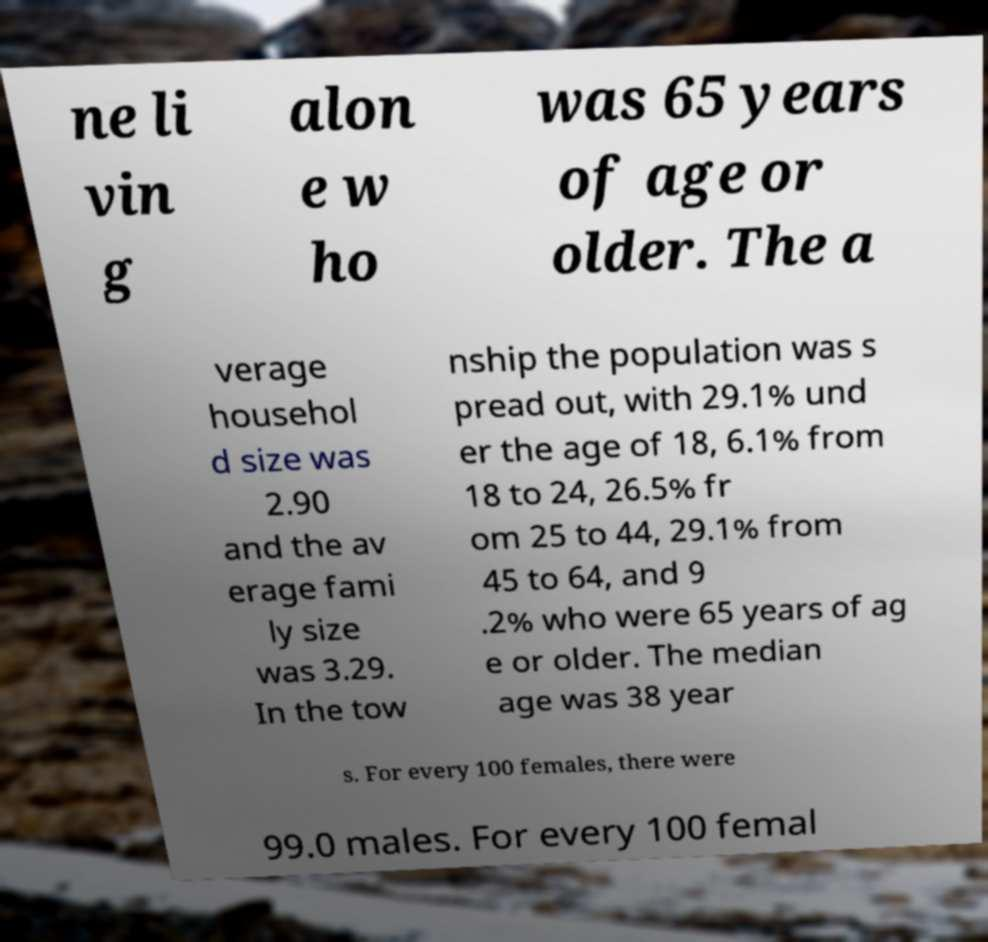Can you accurately transcribe the text from the provided image for me? ne li vin g alon e w ho was 65 years of age or older. The a verage househol d size was 2.90 and the av erage fami ly size was 3.29. In the tow nship the population was s pread out, with 29.1% und er the age of 18, 6.1% from 18 to 24, 26.5% fr om 25 to 44, 29.1% from 45 to 64, and 9 .2% who were 65 years of ag e or older. The median age was 38 year s. For every 100 females, there were 99.0 males. For every 100 femal 